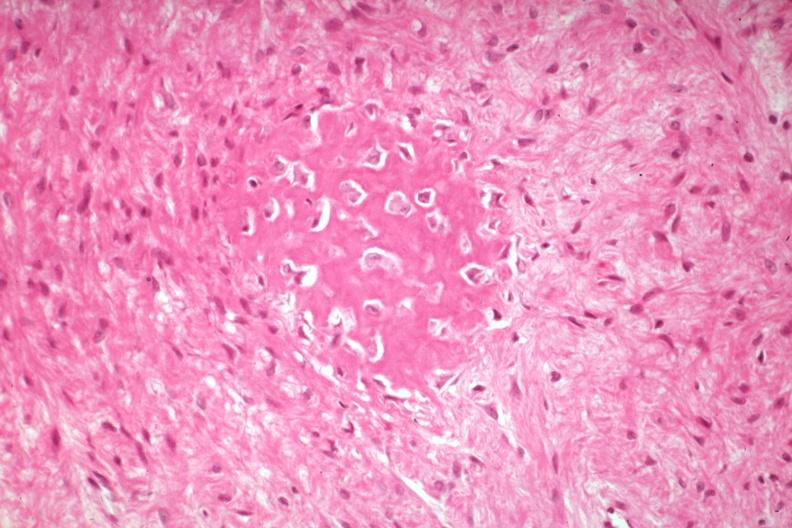s joints present?
Answer the question using a single word or phrase. Yes 